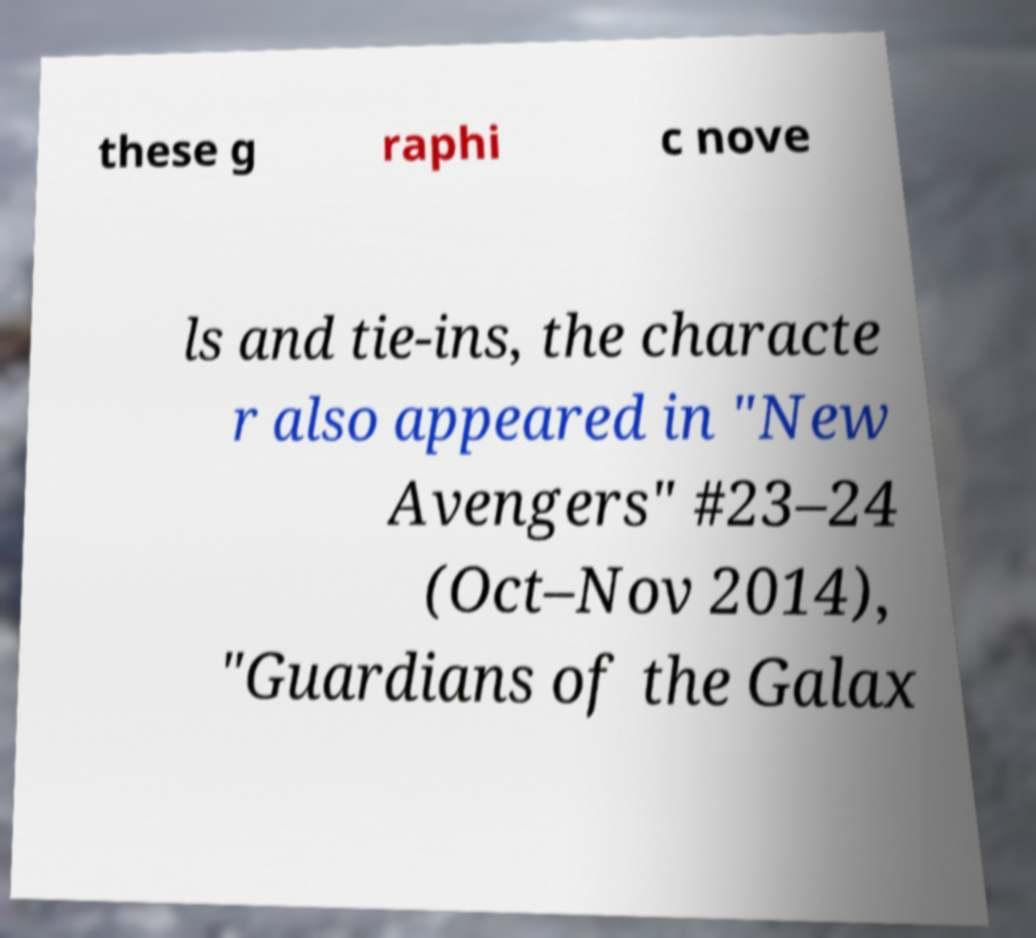Please read and relay the text visible in this image. What does it say? these g raphi c nove ls and tie-ins, the characte r also appeared in "New Avengers" #23–24 (Oct–Nov 2014), "Guardians of the Galax 